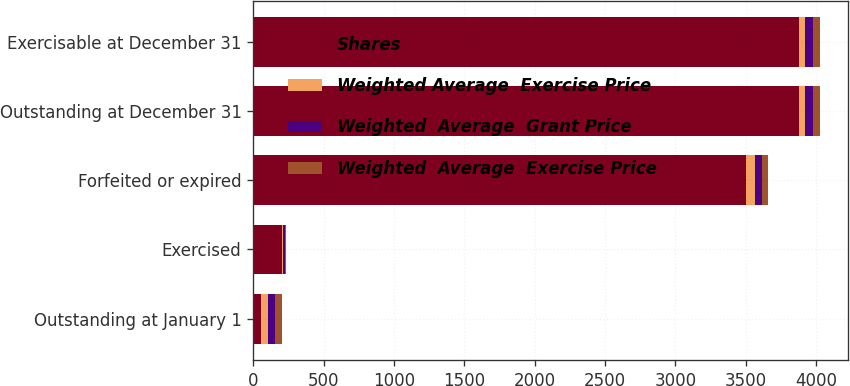Convert chart. <chart><loc_0><loc_0><loc_500><loc_500><stacked_bar_chart><ecel><fcel>Outstanding at January 1<fcel>Exercised<fcel>Forfeited or expired<fcel>Outstanding at December 31<fcel>Exercisable at December 31<nl><fcel>Shares<fcel>52.01<fcel>205<fcel>3502<fcel>3877<fcel>3877<nl><fcel>Weighted Average  Exercise Price<fcel>53.88<fcel>10.32<fcel>66.25<fcel>45<fcel>45<nl><fcel>Weighted  Average  Grant Price<fcel>52.01<fcel>9.25<fcel>49.61<fcel>53.88<fcel>53.88<nl><fcel>Weighted  Average  Exercise Price<fcel>49.29<fcel>8.76<fcel>40.54<fcel>52.01<fcel>52.01<nl></chart> 